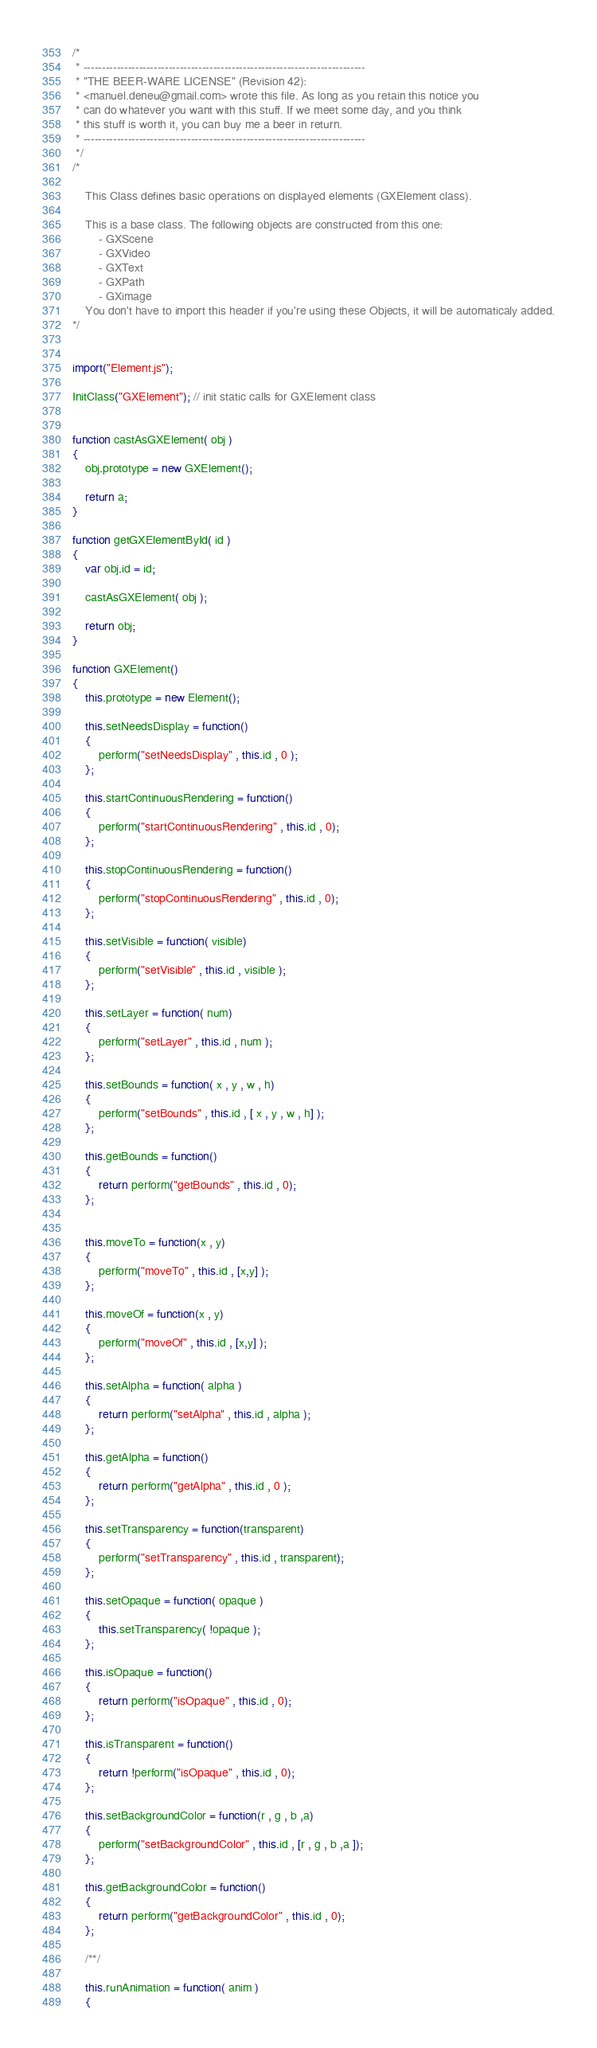<code> <loc_0><loc_0><loc_500><loc_500><_JavaScript_>/*
 * ----------------------------------------------------------------------------
 * "THE BEER-WARE LICENSE" (Revision 42):
 * <manuel.deneu@gmail.com> wrote this file. As long as you retain this notice you
 * can do whatever you want with this stuff. If we meet some day, and you think
 * this stuff is worth it, you can buy me a beer in return.
 * ----------------------------------------------------------------------------
 */
/*

    This Class defines basic operations on displayed elements (GXElement class).

    This is a base class. The following objects are constructed from this one:
        - GXScene
        - GXVideo
        - GXText
        - GXPath
        - GXimage
    You don't have to import this header if you're using these Objects, it will be automaticaly added.
*/


import("Element.js");

InitClass("GXElement"); // init static calls for GXElement class


function castAsGXElement( obj )
{
    obj.prototype = new GXElement();
    
    return a;
}

function getGXElementById( id )
{
    var obj.id = id;
    
    castAsGXElement( obj );
    
    return obj;
}

function GXElement() 
{
    this.prototype = new Element();

    this.setNeedsDisplay = function()
    {
        perform("setNeedsDisplay" , this.id , 0 );
    };
    
    this.startContinuousRendering = function()
    {
        perform("startContinuousRendering" , this.id , 0);
    };
    
    this.stopContinuousRendering = function()
    {
        perform("stopContinuousRendering" , this.id , 0);
    };
    
    this.setVisible = function( visible)
    {
        perform("setVisible" , this.id , visible );
    };
    
    this.setLayer = function( num)
    {
        perform("setLayer" , this.id , num );
    };
    
    this.setBounds = function( x , y , w , h)
    {
        perform("setBounds" , this.id , [ x , y , w , h] );
    };
    
    this.getBounds = function()
    {
        return perform("getBounds" , this.id , 0);
    };
    
    
    this.moveTo = function(x , y)
    {
        perform("moveTo" , this.id , [x,y] );
    };
    
    this.moveOf = function(x , y)
    {
        perform("moveOf" , this.id , [x,y] );
    };
    
    this.setAlpha = function( alpha )
    {
        return perform("setAlpha" , this.id , alpha );
    };
    
    this.getAlpha = function()
    {
        return perform("getAlpha" , this.id , 0 );
    };
    
    this.setTransparency = function(transparent)
    {
        perform("setTransparency" , this.id , transparent);
    };
    
    this.setOpaque = function( opaque )
    {
        this.setTransparency( !opaque );
    };
    
    this.isOpaque = function()
    {
        return perform("isOpaque" , this.id , 0);
    };
    
    this.isTransparent = function()
    {
        return !perform("isOpaque" , this.id , 0);
    };
    
    this.setBackgroundColor = function(r , g , b ,a)
    {
        perform("setBackgroundColor" , this.id , [r , g , b ,a ]);
    };
    
    this.getBackgroundColor = function()
    {
        return perform("getBackgroundColor" , this.id , 0);
    };
    
    /**/
    
    this.runAnimation = function( anim )
    {</code> 